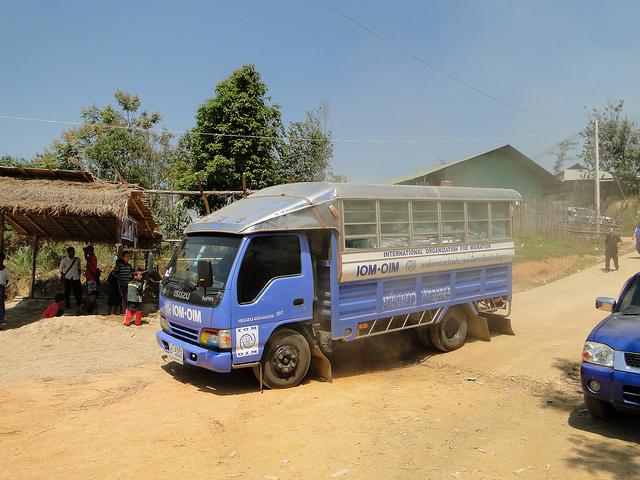What kind of vehicle is shown?
Concise answer only. Truck. Is this in France?
Answer briefly. No. What substance is flying through the air?
Be succinct. Dirt. 